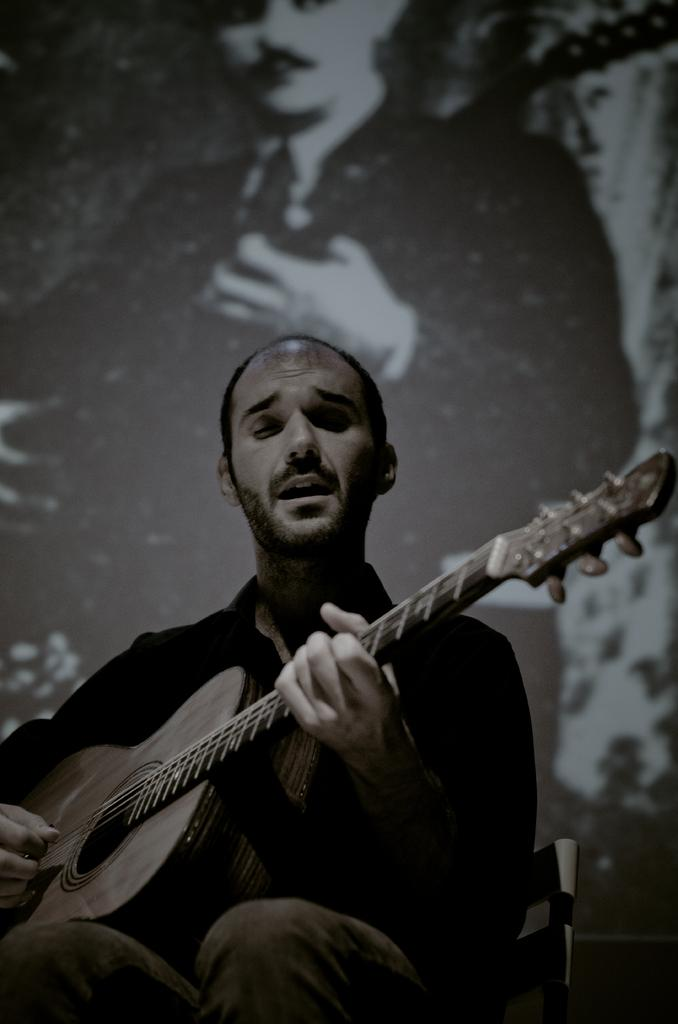Who is present in the image? There is a man in the image. What is the man doing in the image? The man is sitting and playing a guitar. Can you describe anything on the wall in the image? Yes, there is a picture on the wall in the image. How many pizzas are on the table in the image? There is no table or pizzas present in the image. What type of birds can be seen flying outside the window in the image? There is no window or birds visible in the image. 